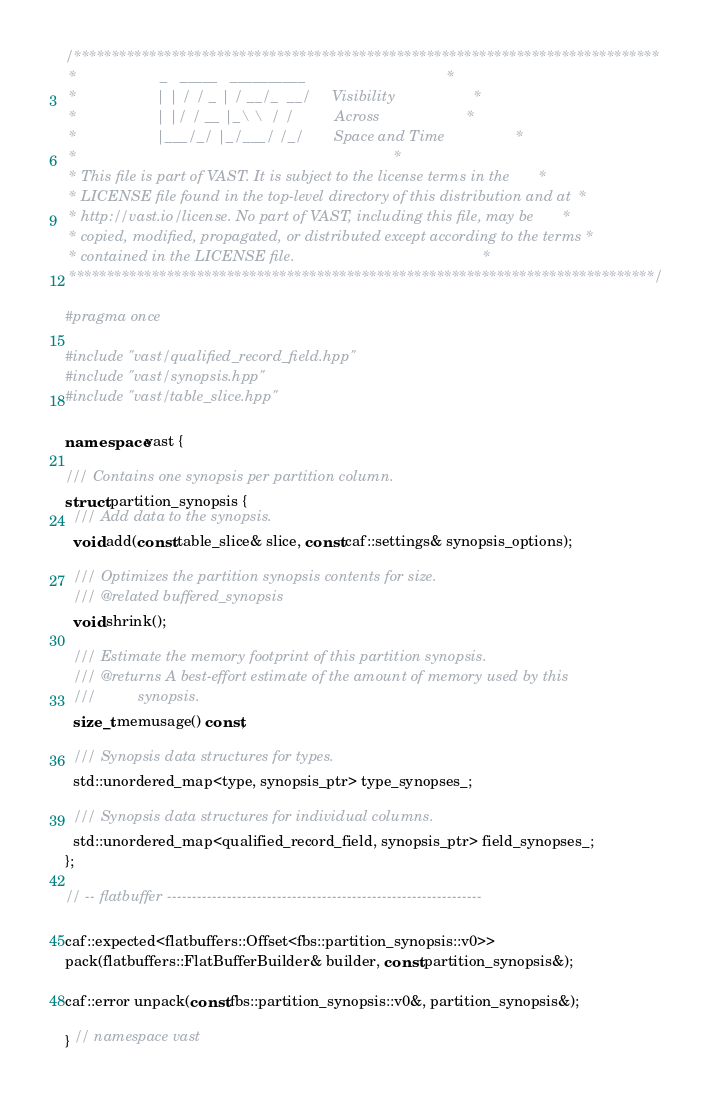Convert code to text. <code><loc_0><loc_0><loc_500><loc_500><_C++_>/******************************************************************************
 *                    _   _____   __________                                  *
 *                   | | / / _ | / __/_  __/     Visibility                   *
 *                   | |/ / __ |_\ \  / /          Across                     *
 *                   |___/_/ |_/___/ /_/       Space and Time                 *
 *                                                                            *
 * This file is part of VAST. It is subject to the license terms in the       *
 * LICENSE file found in the top-level directory of this distribution and at  *
 * http://vast.io/license. No part of VAST, including this file, may be       *
 * copied, modified, propagated, or distributed except according to the terms *
 * contained in the LICENSE file.                                             *
 ******************************************************************************/

#pragma once

#include "vast/qualified_record_field.hpp"
#include "vast/synopsis.hpp"
#include "vast/table_slice.hpp"

namespace vast {

/// Contains one synopsis per partition column.
struct partition_synopsis {
  /// Add data to the synopsis.
  void add(const table_slice& slice, const caf::settings& synopsis_options);

  /// Optimizes the partition synopsis contents for size.
  /// @related buffered_synopsis
  void shrink();

  /// Estimate the memory footprint of this partition synopsis.
  /// @returns A best-effort estimate of the amount of memory used by this
  ///          synopsis.
  size_t memusage() const;

  /// Synopsis data structures for types.
  std::unordered_map<type, synopsis_ptr> type_synopses_;

  /// Synopsis data structures for individual columns.
  std::unordered_map<qualified_record_field, synopsis_ptr> field_synopses_;
};

// -- flatbuffer ---------------------------------------------------------------

caf::expected<flatbuffers::Offset<fbs::partition_synopsis::v0>>
pack(flatbuffers::FlatBufferBuilder& builder, const partition_synopsis&);

caf::error unpack(const fbs::partition_synopsis::v0&, partition_synopsis&);

} // namespace vast
</code> 